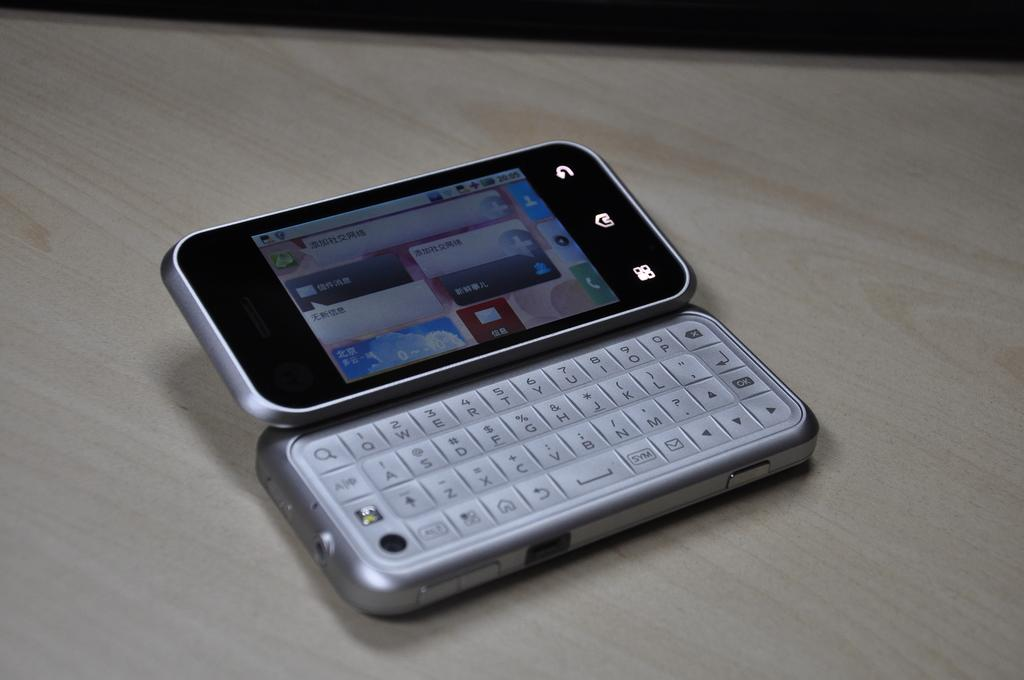Provide a one-sentence caption for the provided image. A cellphone sitting on a table with chinese writing on the screen but the keyboard has english letters like A,B,C,D. 